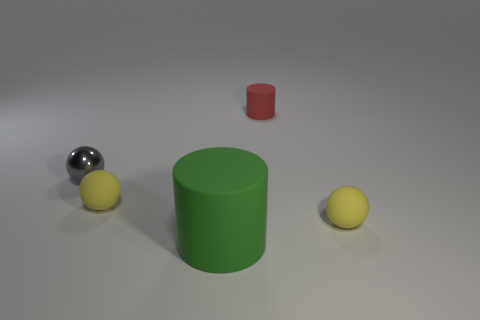Is there anything else that has the same material as the gray thing?
Your response must be concise. No. Does the big rubber thing have the same shape as the small metallic object?
Your response must be concise. No. What is the size of the other red object that is the same shape as the large thing?
Make the answer very short. Small. Does the rubber ball that is on the right side of the red cylinder have the same size as the large matte object?
Offer a very short reply. No. How big is the rubber object that is in front of the small red thing and right of the big rubber cylinder?
Your answer should be compact. Small. What number of tiny matte cylinders have the same color as the small metallic thing?
Give a very brief answer. 0. Are there the same number of metallic balls that are in front of the metallic thing and gray metal things?
Offer a very short reply. No. What is the color of the shiny ball?
Provide a short and direct response. Gray. What size is the cylinder that is the same material as the green thing?
Ensure brevity in your answer.  Small. The large cylinder that is made of the same material as the tiny red object is what color?
Offer a very short reply. Green. 